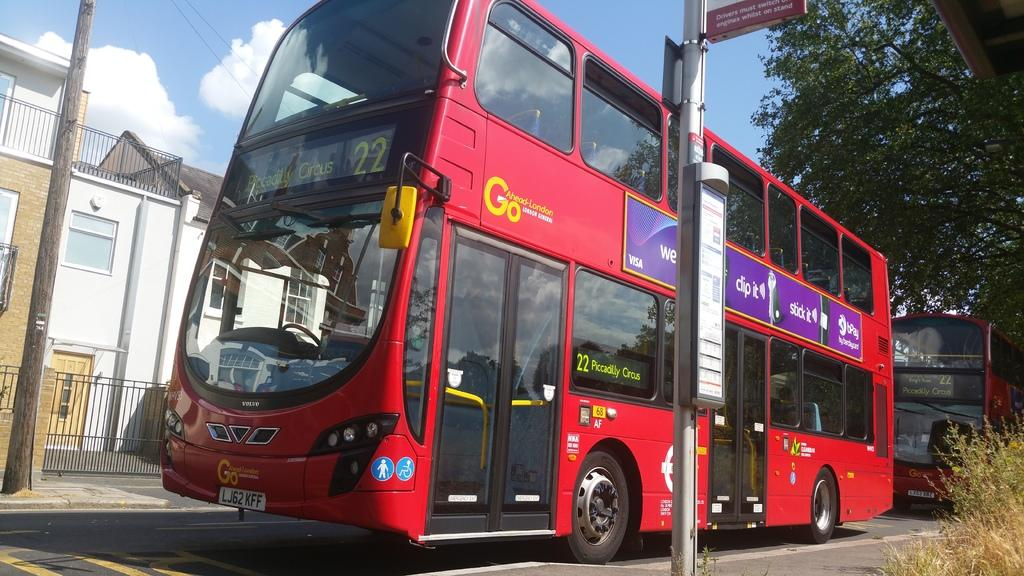What type of vehicles are on the road in the image? There are two buses on the road in the image. Where are the buses located in relation to the road? The buses are on the road. What is located beside the road in the image? There is a pole beside the road. What can be seen on the other side of the buses? There are houses on the other side of the buses. What type of vegetation is visible behind the buses? There are trees visible behind the buses. What type of behavior does the sneeze exhibit in the image? There is no sneeze present in the image, so it cannot exhibit any behavior. 